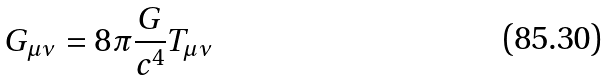Convert formula to latex. <formula><loc_0><loc_0><loc_500><loc_500>G _ { \mu \nu } = 8 \pi { \frac { G } { c ^ { 4 } } } T _ { \mu \nu }</formula> 